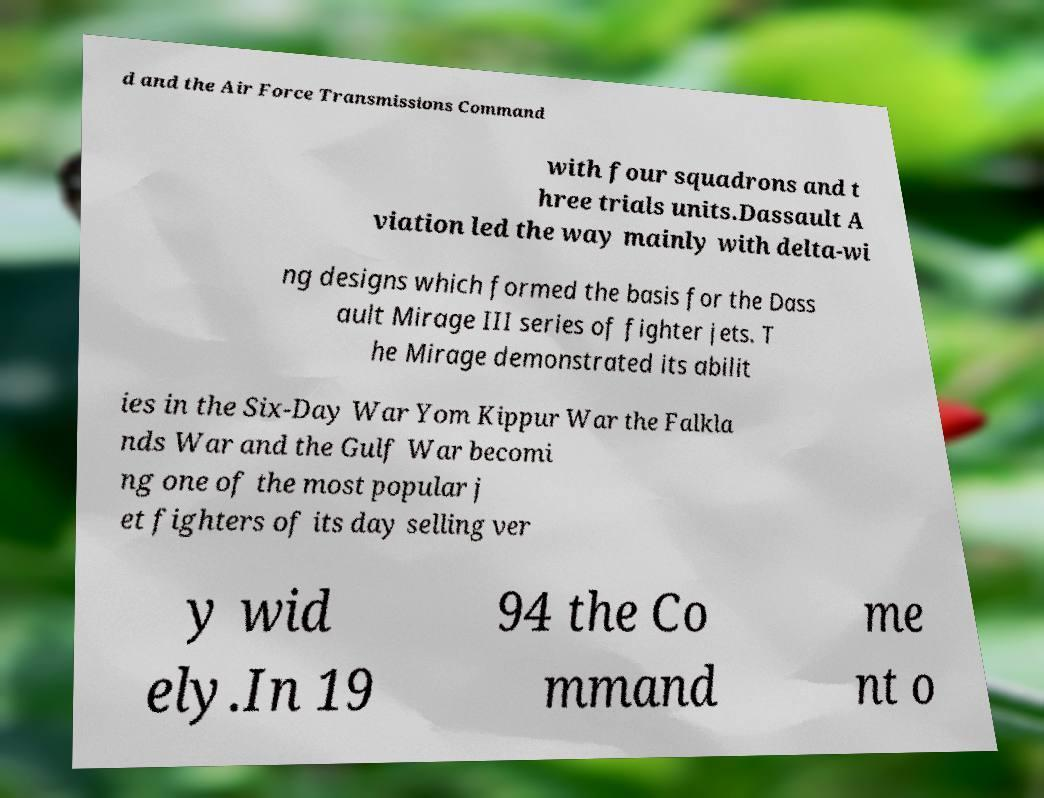For documentation purposes, I need the text within this image transcribed. Could you provide that? d and the Air Force Transmissions Command with four squadrons and t hree trials units.Dassault A viation led the way mainly with delta-wi ng designs which formed the basis for the Dass ault Mirage III series of fighter jets. T he Mirage demonstrated its abilit ies in the Six-Day War Yom Kippur War the Falkla nds War and the Gulf War becomi ng one of the most popular j et fighters of its day selling ver y wid ely.In 19 94 the Co mmand me nt o 